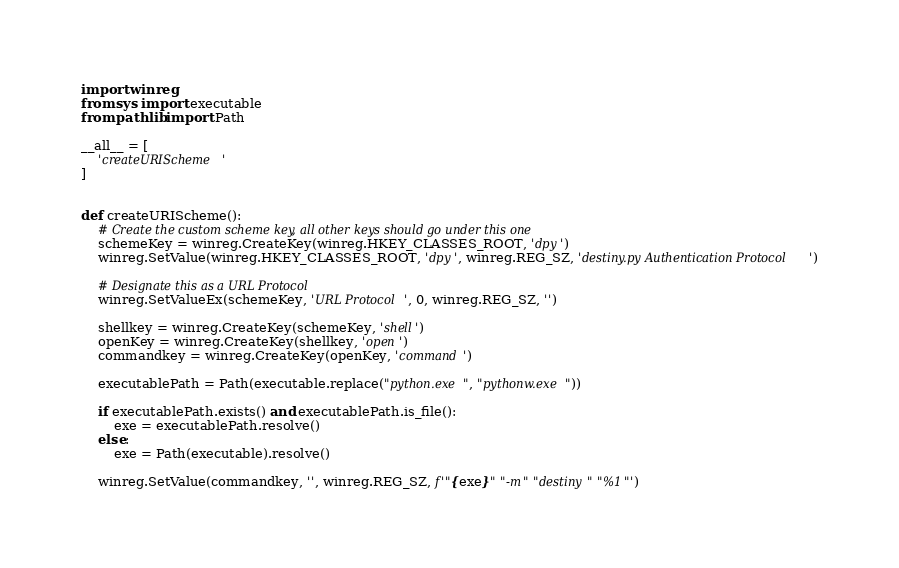<code> <loc_0><loc_0><loc_500><loc_500><_Python_>import winreg
from sys import executable
from pathlib import Path

__all__ = [
    'createURIScheme'
]


def createURIScheme():
    # Create the custom scheme key, all other keys should go under this one
    schemeKey = winreg.CreateKey(winreg.HKEY_CLASSES_ROOT, 'dpy')
    winreg.SetValue(winreg.HKEY_CLASSES_ROOT, 'dpy', winreg.REG_SZ, 'destiny.py Authentication Protocol')

    # Designate this as a URL Protocol
    winreg.SetValueEx(schemeKey, 'URL Protocol', 0, winreg.REG_SZ, '')

    shellkey = winreg.CreateKey(schemeKey, 'shell')
    openKey = winreg.CreateKey(shellkey, 'open')
    commandkey = winreg.CreateKey(openKey, 'command')

    executablePath = Path(executable.replace("python.exe", "pythonw.exe"))

    if executablePath.exists() and executablePath.is_file():
        exe = executablePath.resolve()
    else:
        exe = Path(executable).resolve()

    winreg.SetValue(commandkey, '', winreg.REG_SZ, f'"{exe}" "-m" "destiny" "%1"')
</code> 